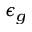<formula> <loc_0><loc_0><loc_500><loc_500>\epsilon _ { g }</formula> 